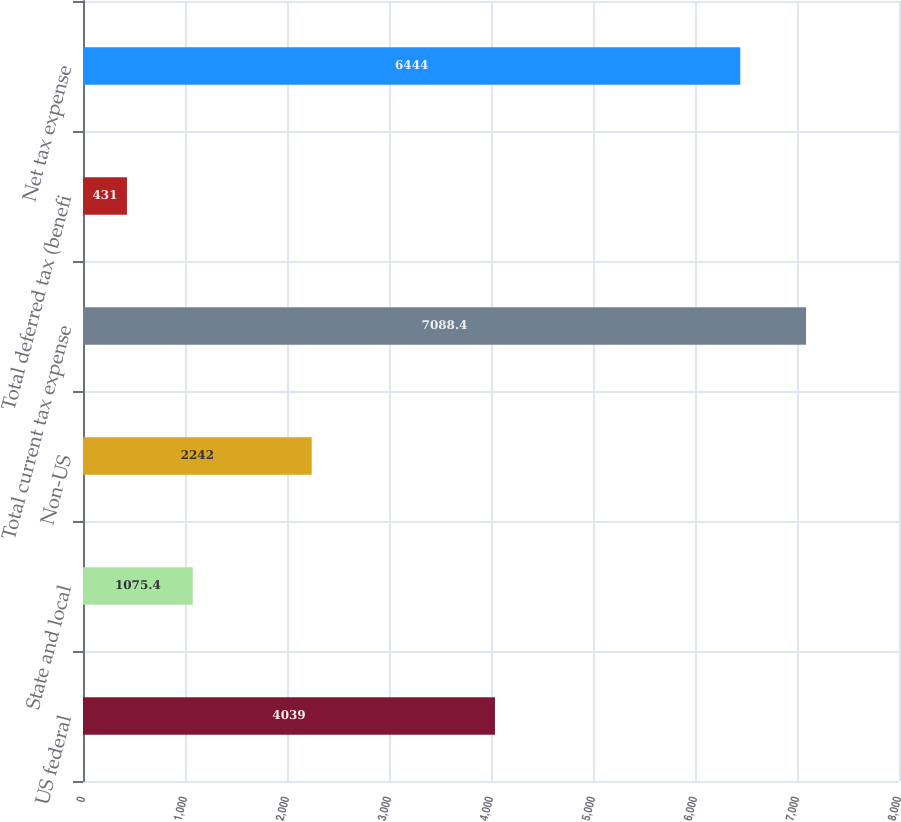Convert chart to OTSL. <chart><loc_0><loc_0><loc_500><loc_500><bar_chart><fcel>US federal<fcel>State and local<fcel>Non-US<fcel>Total current tax expense<fcel>Total deferred tax (benefi<fcel>Net tax expense<nl><fcel>4039<fcel>1075.4<fcel>2242<fcel>7088.4<fcel>431<fcel>6444<nl></chart> 